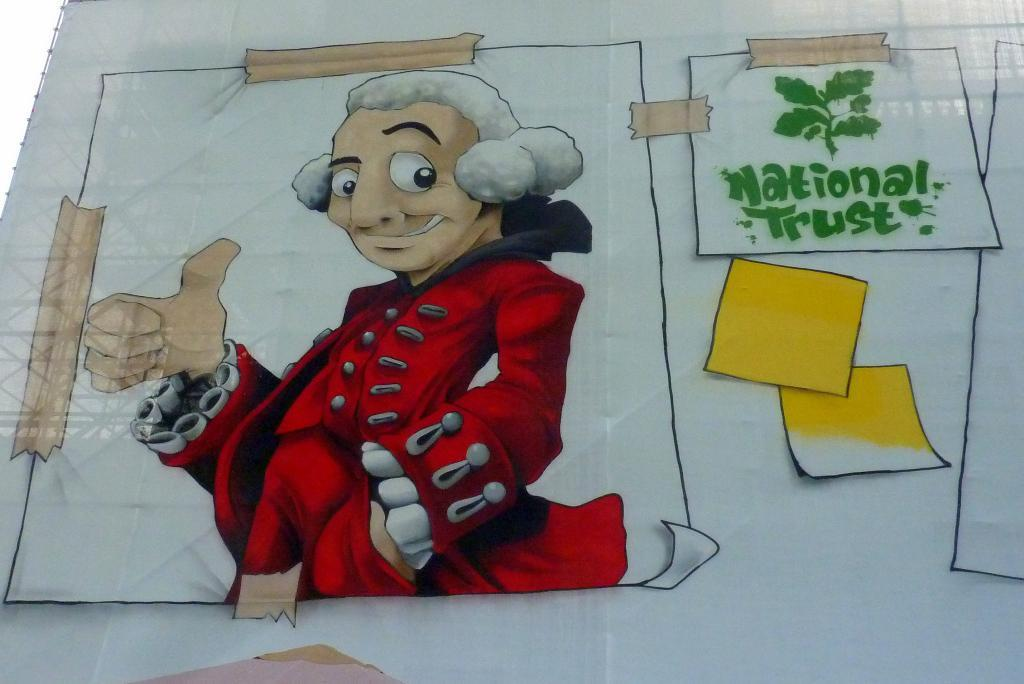<image>
Present a compact description of the photo's key features. A cartoon image of a man with a white wig and red coat next to a smaller paper that reads National Trust. 